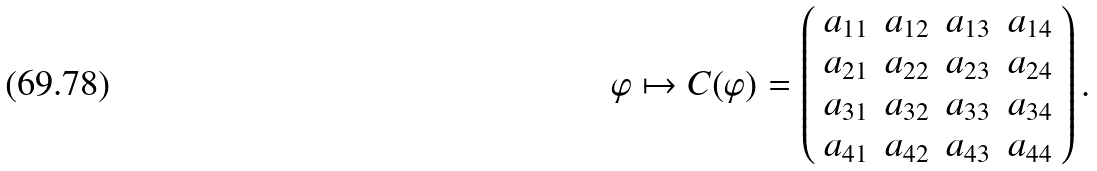Convert formula to latex. <formula><loc_0><loc_0><loc_500><loc_500>\varphi \mapsto C ( \varphi ) = \left ( \begin{array} { l l l l } a _ { 1 1 } & a _ { 1 2 } & a _ { 1 3 } & a _ { 1 4 } \\ a _ { 2 1 } & a _ { 2 2 } & a _ { 2 3 } & a _ { 2 4 } \\ a _ { 3 1 } & a _ { 3 2 } & a _ { 3 3 } & a _ { 3 4 } \\ a _ { 4 1 } & a _ { 4 2 } & a _ { 4 3 } & a _ { 4 4 } \end{array} \right ) .</formula> 